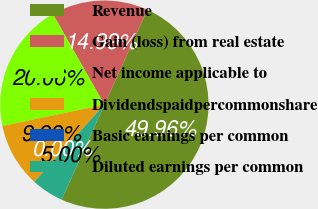Convert chart. <chart><loc_0><loc_0><loc_500><loc_500><pie_chart><fcel>Revenue<fcel>Gain (loss) from real estate<fcel>Net income applicable to<fcel>Dividendspaidpercommonshare<fcel>Basic earnings per common<fcel>Diluted earnings per common<nl><fcel>49.96%<fcel>14.99%<fcel>20.06%<fcel>9.99%<fcel>0.0%<fcel>5.0%<nl></chart> 